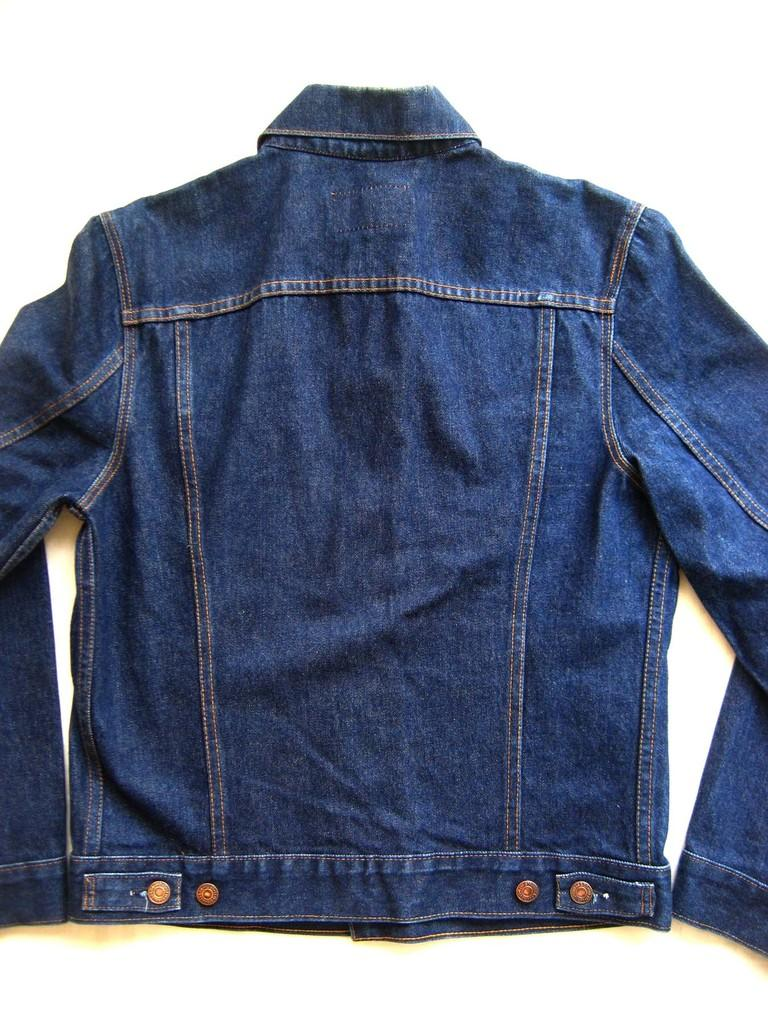What color is the jacket that is visible in the image? There is a blue color jacket in the image. What type of war strategy is depicted on the map in the image? There is no map or war strategy present in the image; it only features a blue color jacket. How many tents are visible in the image? There are no tents present in the image; it only features a blue color jacket. 